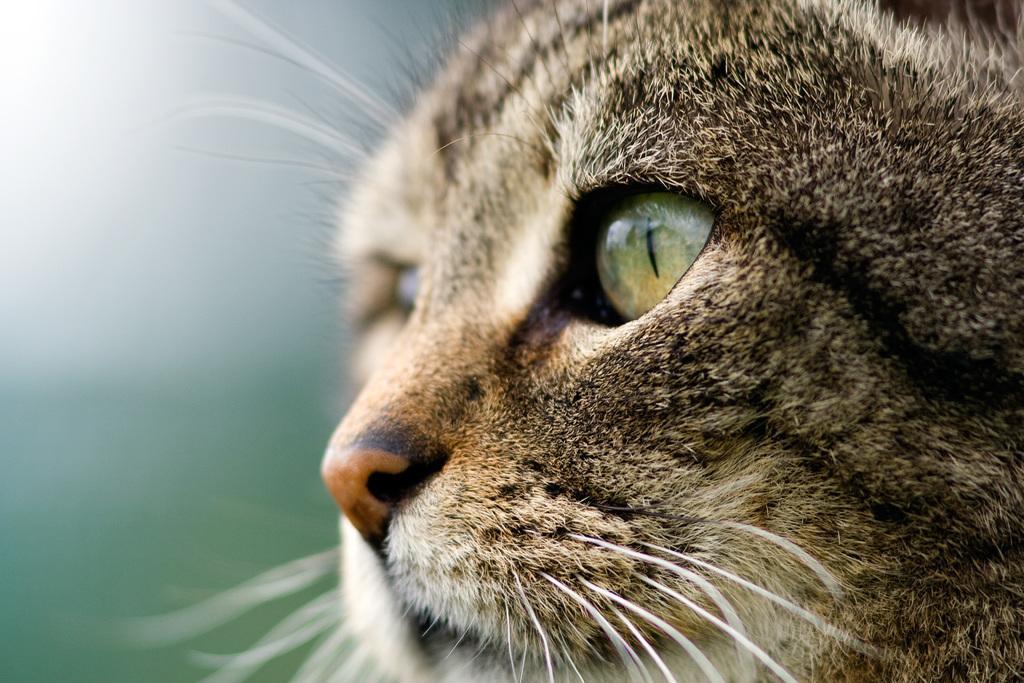How would you summarize this image in a sentence or two? This is the close up view of a cat. The background is blurred. 